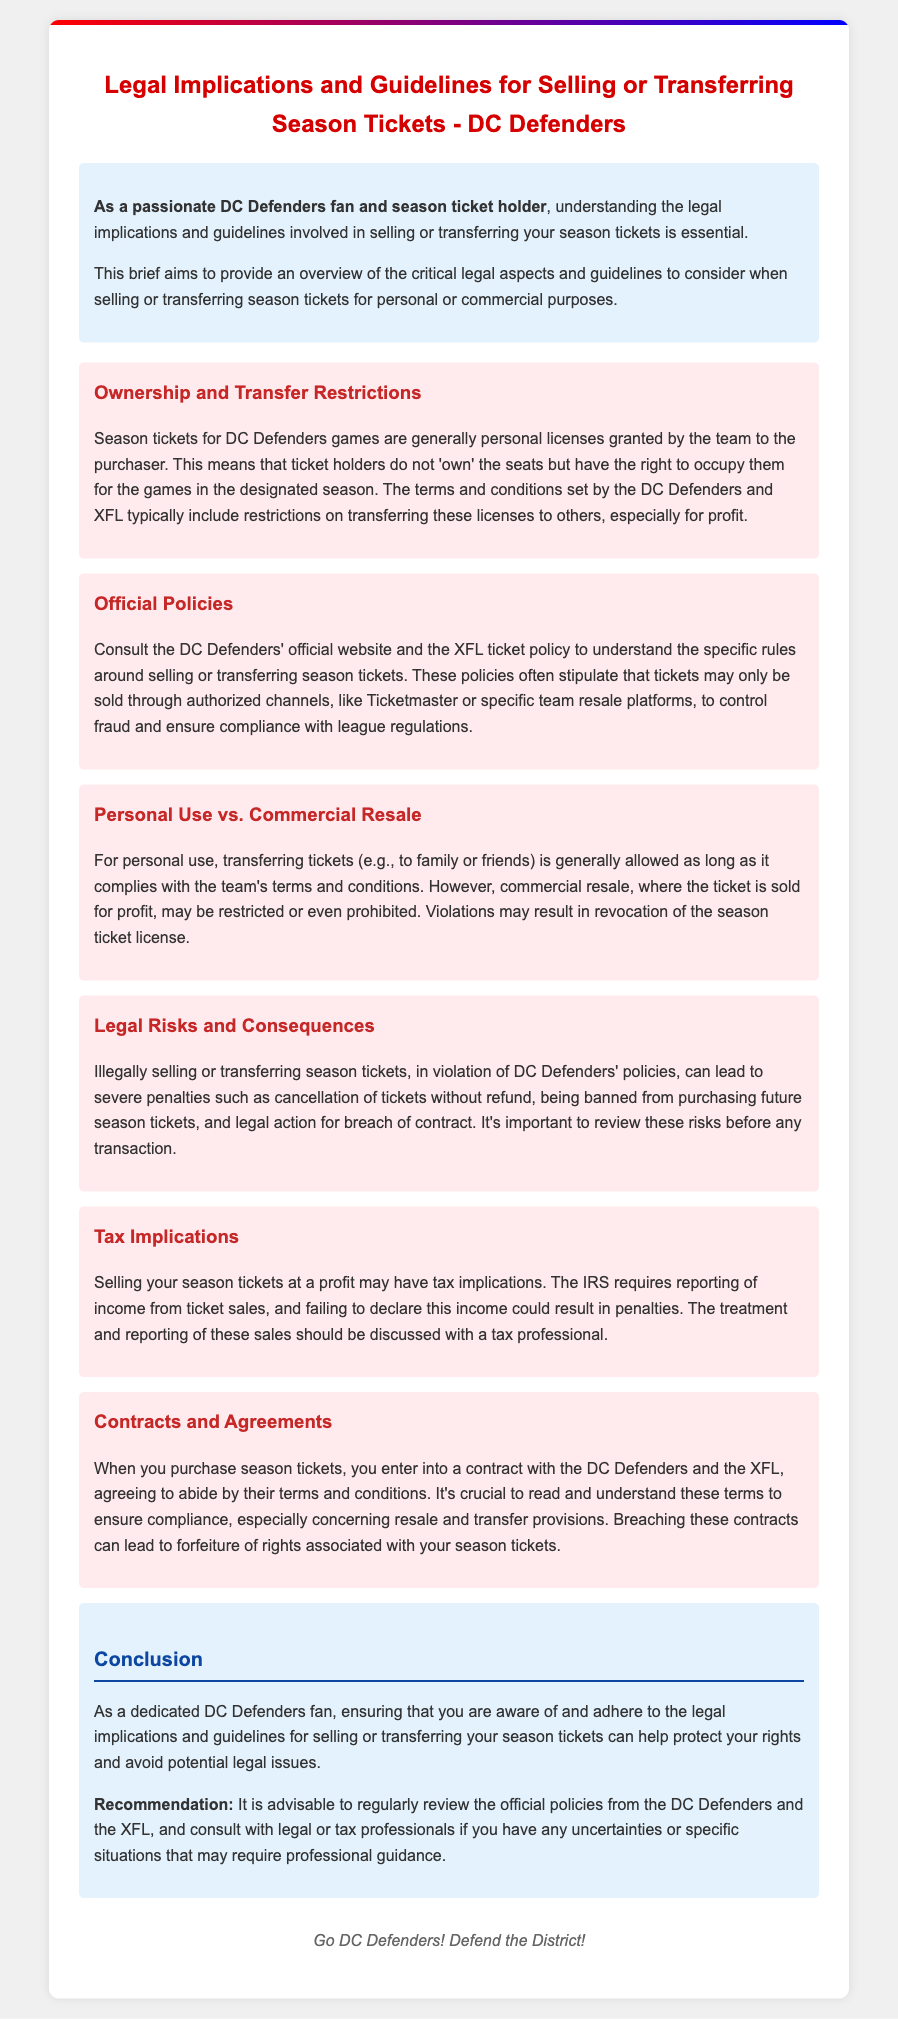What is the title of the document? The title refers to the main subject of the legal brief, which is provided in the heading of the document.
Answer: Legal Implications and Guidelines for Selling or Transferring Season Tickets - DC Defenders What is generally granted to season ticket holders? The document states what season tickets represent in terms of ownership or licensing, focusing on the relationship between the holder and the team.
Answer: Personal licenses Where can one find the official policies regarding season ticket transfer? The brief mentions specific sources for validating the rules and regulations, making it a key point of reference.
Answer: DC Defenders' official website What may happen if tickets are sold illegally? This outlines the potential consequences for violating ticket transfer policies, which is a critical aspect of the document.
Answer: Cancellation of tickets without refund What is required if selling tickets at a profit? This touches upon tax obligations relating to selling season tickets, providing guidance for accountability.
Answer: Reporting of income What type of document is this? The nature of the document is identified by its purpose and content focus, which is related to legal aspects.
Answer: Legal brief 